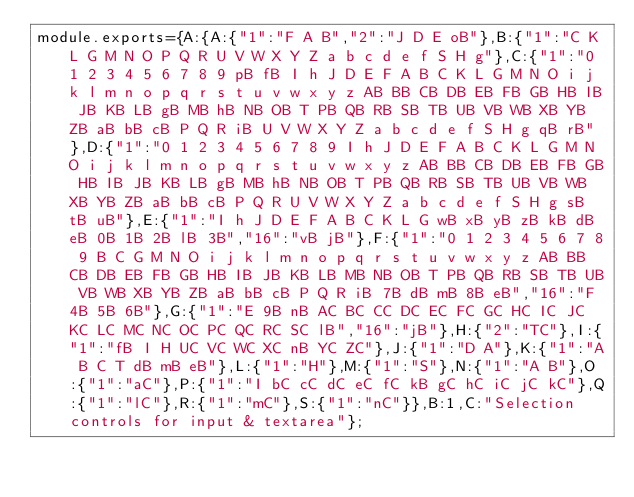Convert code to text. <code><loc_0><loc_0><loc_500><loc_500><_JavaScript_>module.exports={A:{A:{"1":"F A B","2":"J D E oB"},B:{"1":"C K L G M N O P Q R U V W X Y Z a b c d e f S H g"},C:{"1":"0 1 2 3 4 5 6 7 8 9 pB fB I h J D E F A B C K L G M N O i j k l m n o p q r s t u v w x y z AB BB CB DB EB FB GB HB IB JB KB LB gB MB hB NB OB T PB QB RB SB TB UB VB WB XB YB ZB aB bB cB P Q R iB U V W X Y Z a b c d e f S H g qB rB"},D:{"1":"0 1 2 3 4 5 6 7 8 9 I h J D E F A B C K L G M N O i j k l m n o p q r s t u v w x y z AB BB CB DB EB FB GB HB IB JB KB LB gB MB hB NB OB T PB QB RB SB TB UB VB WB XB YB ZB aB bB cB P Q R U V W X Y Z a b c d e f S H g sB tB uB"},E:{"1":"I h J D E F A B C K L G wB xB yB zB kB dB eB 0B 1B 2B lB 3B","16":"vB jB"},F:{"1":"0 1 2 3 4 5 6 7 8 9 B C G M N O i j k l m n o p q r s t u v w x y z AB BB CB DB EB FB GB HB IB JB KB LB MB NB OB T PB QB RB SB TB UB VB WB XB YB ZB aB bB cB P Q R iB 7B dB mB 8B eB","16":"F 4B 5B 6B"},G:{"1":"E 9B nB AC BC CC DC EC FC GC HC IC JC KC LC MC NC OC PC QC RC SC lB","16":"jB"},H:{"2":"TC"},I:{"1":"fB I H UC VC WC XC nB YC ZC"},J:{"1":"D A"},K:{"1":"A B C T dB mB eB"},L:{"1":"H"},M:{"1":"S"},N:{"1":"A B"},O:{"1":"aC"},P:{"1":"I bC cC dC eC fC kB gC hC iC jC kC"},Q:{"1":"lC"},R:{"1":"mC"},S:{"1":"nC"}},B:1,C:"Selection controls for input & textarea"};
</code> 